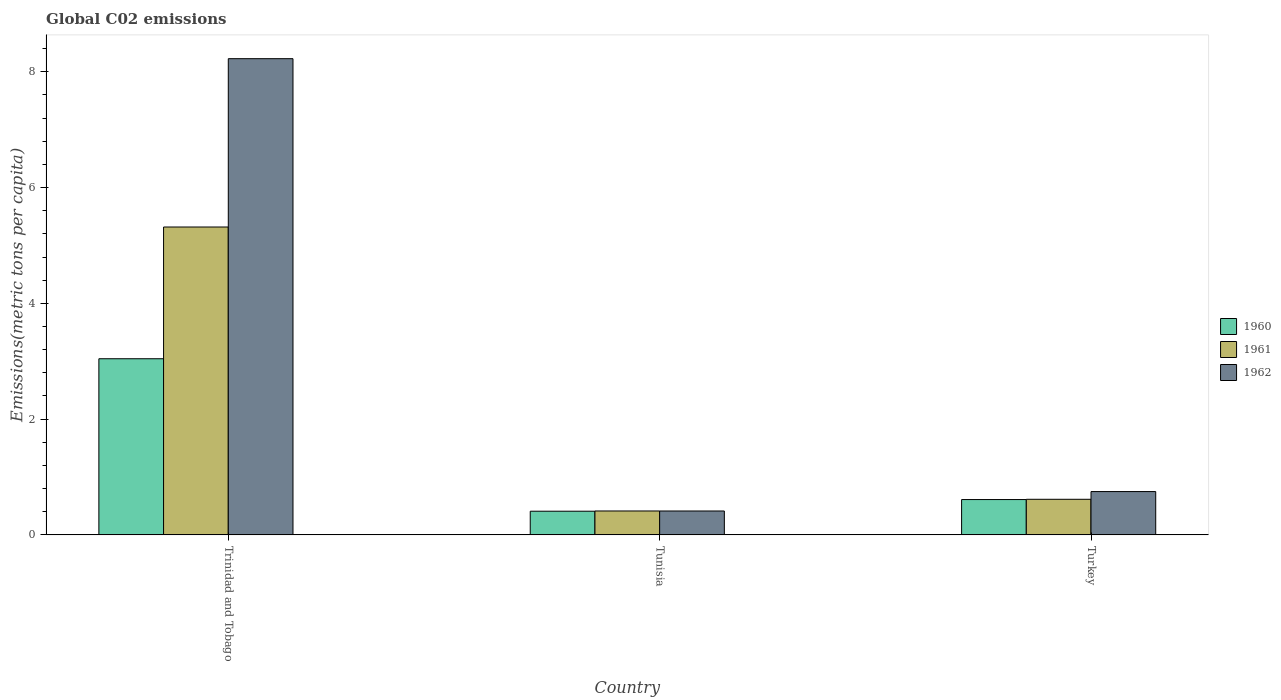How many different coloured bars are there?
Ensure brevity in your answer.  3. How many groups of bars are there?
Ensure brevity in your answer.  3. Are the number of bars per tick equal to the number of legend labels?
Offer a very short reply. Yes. How many bars are there on the 2nd tick from the right?
Ensure brevity in your answer.  3. In how many cases, is the number of bars for a given country not equal to the number of legend labels?
Your answer should be compact. 0. What is the amount of CO2 emitted in in 1962 in Tunisia?
Your answer should be compact. 0.41. Across all countries, what is the maximum amount of CO2 emitted in in 1962?
Your answer should be very brief. 8.23. Across all countries, what is the minimum amount of CO2 emitted in in 1962?
Offer a terse response. 0.41. In which country was the amount of CO2 emitted in in 1961 maximum?
Your answer should be very brief. Trinidad and Tobago. In which country was the amount of CO2 emitted in in 1962 minimum?
Offer a terse response. Tunisia. What is the total amount of CO2 emitted in in 1960 in the graph?
Ensure brevity in your answer.  4.06. What is the difference between the amount of CO2 emitted in in 1962 in Trinidad and Tobago and that in Turkey?
Your answer should be very brief. 7.48. What is the difference between the amount of CO2 emitted in in 1961 in Trinidad and Tobago and the amount of CO2 emitted in in 1962 in Tunisia?
Offer a very short reply. 4.91. What is the average amount of CO2 emitted in in 1960 per country?
Give a very brief answer. 1.35. What is the difference between the amount of CO2 emitted in of/in 1960 and amount of CO2 emitted in of/in 1962 in Tunisia?
Offer a terse response. -0. What is the ratio of the amount of CO2 emitted in in 1961 in Trinidad and Tobago to that in Tunisia?
Your answer should be compact. 12.87. What is the difference between the highest and the second highest amount of CO2 emitted in in 1961?
Your answer should be very brief. 0.2. What is the difference between the highest and the lowest amount of CO2 emitted in in 1962?
Your answer should be compact. 7.81. In how many countries, is the amount of CO2 emitted in in 1962 greater than the average amount of CO2 emitted in in 1962 taken over all countries?
Give a very brief answer. 1. Are all the bars in the graph horizontal?
Your answer should be compact. No. What is the difference between two consecutive major ticks on the Y-axis?
Provide a short and direct response. 2. How many legend labels are there?
Provide a succinct answer. 3. What is the title of the graph?
Your answer should be very brief. Global C02 emissions. Does "2001" appear as one of the legend labels in the graph?
Give a very brief answer. No. What is the label or title of the X-axis?
Provide a succinct answer. Country. What is the label or title of the Y-axis?
Provide a succinct answer. Emissions(metric tons per capita). What is the Emissions(metric tons per capita) in 1960 in Trinidad and Tobago?
Your answer should be very brief. 3.04. What is the Emissions(metric tons per capita) in 1961 in Trinidad and Tobago?
Your answer should be compact. 5.32. What is the Emissions(metric tons per capita) of 1962 in Trinidad and Tobago?
Keep it short and to the point. 8.23. What is the Emissions(metric tons per capita) in 1960 in Tunisia?
Make the answer very short. 0.41. What is the Emissions(metric tons per capita) of 1961 in Tunisia?
Provide a succinct answer. 0.41. What is the Emissions(metric tons per capita) of 1962 in Tunisia?
Give a very brief answer. 0.41. What is the Emissions(metric tons per capita) of 1960 in Turkey?
Provide a short and direct response. 0.61. What is the Emissions(metric tons per capita) in 1961 in Turkey?
Your answer should be compact. 0.62. What is the Emissions(metric tons per capita) in 1962 in Turkey?
Your answer should be very brief. 0.75. Across all countries, what is the maximum Emissions(metric tons per capita) of 1960?
Offer a terse response. 3.04. Across all countries, what is the maximum Emissions(metric tons per capita) in 1961?
Provide a succinct answer. 5.32. Across all countries, what is the maximum Emissions(metric tons per capita) of 1962?
Your answer should be compact. 8.23. Across all countries, what is the minimum Emissions(metric tons per capita) in 1960?
Keep it short and to the point. 0.41. Across all countries, what is the minimum Emissions(metric tons per capita) in 1961?
Ensure brevity in your answer.  0.41. Across all countries, what is the minimum Emissions(metric tons per capita) in 1962?
Make the answer very short. 0.41. What is the total Emissions(metric tons per capita) of 1960 in the graph?
Provide a short and direct response. 4.06. What is the total Emissions(metric tons per capita) of 1961 in the graph?
Your answer should be compact. 6.35. What is the total Emissions(metric tons per capita) of 1962 in the graph?
Provide a short and direct response. 9.39. What is the difference between the Emissions(metric tons per capita) of 1960 in Trinidad and Tobago and that in Tunisia?
Ensure brevity in your answer.  2.63. What is the difference between the Emissions(metric tons per capita) of 1961 in Trinidad and Tobago and that in Tunisia?
Keep it short and to the point. 4.9. What is the difference between the Emissions(metric tons per capita) of 1962 in Trinidad and Tobago and that in Tunisia?
Your response must be concise. 7.81. What is the difference between the Emissions(metric tons per capita) of 1960 in Trinidad and Tobago and that in Turkey?
Make the answer very short. 2.43. What is the difference between the Emissions(metric tons per capita) of 1961 in Trinidad and Tobago and that in Turkey?
Provide a succinct answer. 4.7. What is the difference between the Emissions(metric tons per capita) of 1962 in Trinidad and Tobago and that in Turkey?
Offer a terse response. 7.48. What is the difference between the Emissions(metric tons per capita) in 1960 in Tunisia and that in Turkey?
Your answer should be very brief. -0.2. What is the difference between the Emissions(metric tons per capita) in 1961 in Tunisia and that in Turkey?
Give a very brief answer. -0.2. What is the difference between the Emissions(metric tons per capita) of 1962 in Tunisia and that in Turkey?
Your answer should be compact. -0.34. What is the difference between the Emissions(metric tons per capita) in 1960 in Trinidad and Tobago and the Emissions(metric tons per capita) in 1961 in Tunisia?
Provide a short and direct response. 2.63. What is the difference between the Emissions(metric tons per capita) in 1960 in Trinidad and Tobago and the Emissions(metric tons per capita) in 1962 in Tunisia?
Your answer should be very brief. 2.63. What is the difference between the Emissions(metric tons per capita) in 1961 in Trinidad and Tobago and the Emissions(metric tons per capita) in 1962 in Tunisia?
Offer a very short reply. 4.91. What is the difference between the Emissions(metric tons per capita) in 1960 in Trinidad and Tobago and the Emissions(metric tons per capita) in 1961 in Turkey?
Your answer should be very brief. 2.43. What is the difference between the Emissions(metric tons per capita) of 1960 in Trinidad and Tobago and the Emissions(metric tons per capita) of 1962 in Turkey?
Give a very brief answer. 2.29. What is the difference between the Emissions(metric tons per capita) of 1961 in Trinidad and Tobago and the Emissions(metric tons per capita) of 1962 in Turkey?
Your answer should be compact. 4.57. What is the difference between the Emissions(metric tons per capita) in 1960 in Tunisia and the Emissions(metric tons per capita) in 1961 in Turkey?
Make the answer very short. -0.21. What is the difference between the Emissions(metric tons per capita) in 1960 in Tunisia and the Emissions(metric tons per capita) in 1962 in Turkey?
Offer a very short reply. -0.34. What is the difference between the Emissions(metric tons per capita) in 1961 in Tunisia and the Emissions(metric tons per capita) in 1962 in Turkey?
Your answer should be very brief. -0.34. What is the average Emissions(metric tons per capita) in 1960 per country?
Make the answer very short. 1.35. What is the average Emissions(metric tons per capita) of 1961 per country?
Offer a terse response. 2.12. What is the average Emissions(metric tons per capita) in 1962 per country?
Your answer should be very brief. 3.13. What is the difference between the Emissions(metric tons per capita) of 1960 and Emissions(metric tons per capita) of 1961 in Trinidad and Tobago?
Ensure brevity in your answer.  -2.28. What is the difference between the Emissions(metric tons per capita) in 1960 and Emissions(metric tons per capita) in 1962 in Trinidad and Tobago?
Provide a succinct answer. -5.18. What is the difference between the Emissions(metric tons per capita) of 1961 and Emissions(metric tons per capita) of 1962 in Trinidad and Tobago?
Provide a succinct answer. -2.91. What is the difference between the Emissions(metric tons per capita) of 1960 and Emissions(metric tons per capita) of 1961 in Tunisia?
Make the answer very short. -0. What is the difference between the Emissions(metric tons per capita) in 1960 and Emissions(metric tons per capita) in 1962 in Tunisia?
Ensure brevity in your answer.  -0. What is the difference between the Emissions(metric tons per capita) in 1961 and Emissions(metric tons per capita) in 1962 in Tunisia?
Your answer should be very brief. 0. What is the difference between the Emissions(metric tons per capita) in 1960 and Emissions(metric tons per capita) in 1961 in Turkey?
Your answer should be compact. -0. What is the difference between the Emissions(metric tons per capita) of 1960 and Emissions(metric tons per capita) of 1962 in Turkey?
Make the answer very short. -0.14. What is the difference between the Emissions(metric tons per capita) in 1961 and Emissions(metric tons per capita) in 1962 in Turkey?
Make the answer very short. -0.13. What is the ratio of the Emissions(metric tons per capita) of 1960 in Trinidad and Tobago to that in Tunisia?
Your answer should be very brief. 7.44. What is the ratio of the Emissions(metric tons per capita) in 1961 in Trinidad and Tobago to that in Tunisia?
Provide a short and direct response. 12.87. What is the ratio of the Emissions(metric tons per capita) of 1962 in Trinidad and Tobago to that in Tunisia?
Make the answer very short. 19.92. What is the ratio of the Emissions(metric tons per capita) in 1960 in Trinidad and Tobago to that in Turkey?
Provide a short and direct response. 4.98. What is the ratio of the Emissions(metric tons per capita) in 1961 in Trinidad and Tobago to that in Turkey?
Your answer should be very brief. 8.65. What is the ratio of the Emissions(metric tons per capita) in 1962 in Trinidad and Tobago to that in Turkey?
Give a very brief answer. 10.99. What is the ratio of the Emissions(metric tons per capita) in 1960 in Tunisia to that in Turkey?
Your answer should be compact. 0.67. What is the ratio of the Emissions(metric tons per capita) of 1961 in Tunisia to that in Turkey?
Make the answer very short. 0.67. What is the ratio of the Emissions(metric tons per capita) of 1962 in Tunisia to that in Turkey?
Provide a succinct answer. 0.55. What is the difference between the highest and the second highest Emissions(metric tons per capita) in 1960?
Your answer should be compact. 2.43. What is the difference between the highest and the second highest Emissions(metric tons per capita) of 1961?
Keep it short and to the point. 4.7. What is the difference between the highest and the second highest Emissions(metric tons per capita) of 1962?
Your response must be concise. 7.48. What is the difference between the highest and the lowest Emissions(metric tons per capita) in 1960?
Keep it short and to the point. 2.63. What is the difference between the highest and the lowest Emissions(metric tons per capita) of 1961?
Offer a very short reply. 4.9. What is the difference between the highest and the lowest Emissions(metric tons per capita) of 1962?
Keep it short and to the point. 7.81. 